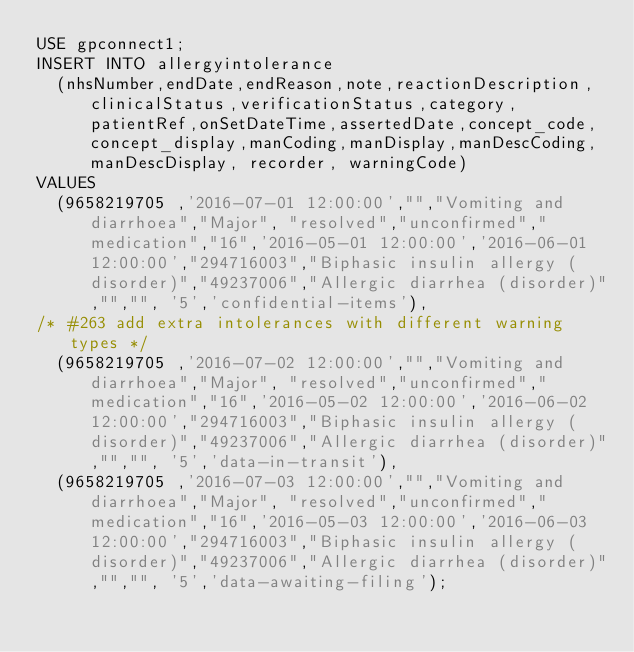Convert code to text. <code><loc_0><loc_0><loc_500><loc_500><_SQL_>USE gpconnect1;
INSERT INTO allergyintolerance
  (nhsNumber,endDate,endReason,note,reactionDescription, clinicalStatus,verificationStatus,category,patientRef,onSetDateTime,assertedDate,concept_code,concept_display,manCoding,manDisplay,manDescCoding,manDescDisplay, recorder, warningCode)
VALUES
  (9658219705 ,'2016-07-01 12:00:00',"","Vomiting and diarrhoea","Major", "resolved","unconfirmed","medication","16",'2016-05-01 12:00:00','2016-06-01 12:00:00',"294716003","Biphasic insulin allergy (disorder)","49237006","Allergic diarrhea (disorder)","","", '5','confidential-items'),
/* #263 add extra intolerances with different warning types */
  (9658219705 ,'2016-07-02 12:00:00',"","Vomiting and diarrhoea","Major", "resolved","unconfirmed","medication","16",'2016-05-02 12:00:00','2016-06-02 12:00:00',"294716003","Biphasic insulin allergy (disorder)","49237006","Allergic diarrhea (disorder)","","", '5','data-in-transit'),
  (9658219705 ,'2016-07-03 12:00:00',"","Vomiting and diarrhoea","Major", "resolved","unconfirmed","medication","16",'2016-05-03 12:00:00','2016-06-03 12:00:00',"294716003","Biphasic insulin allergy (disorder)","49237006","Allergic diarrhea (disorder)","","", '5','data-awaiting-filing');
</code> 